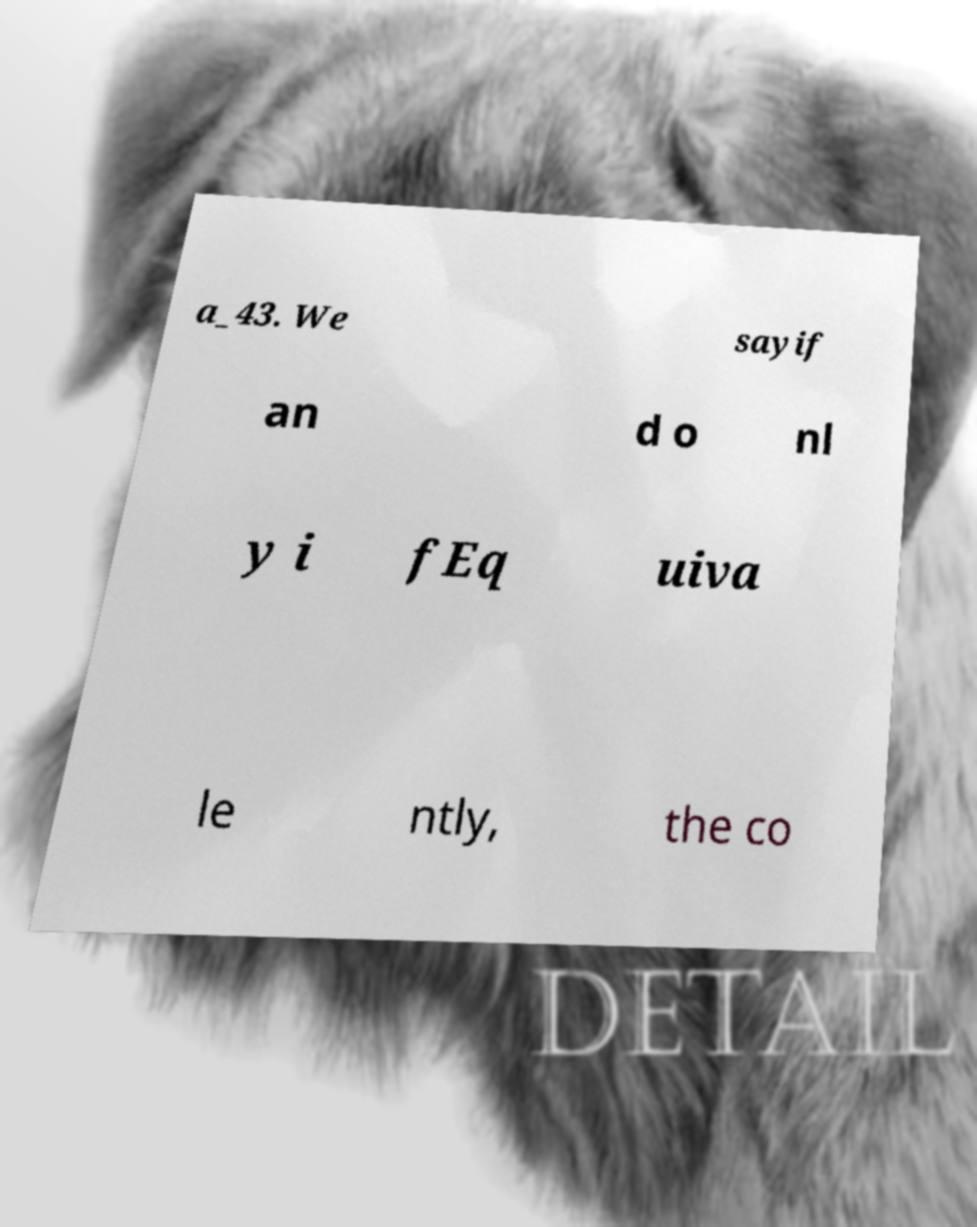Could you assist in decoding the text presented in this image and type it out clearly? a_43. We sayif an d o nl y i fEq uiva le ntly, the co 